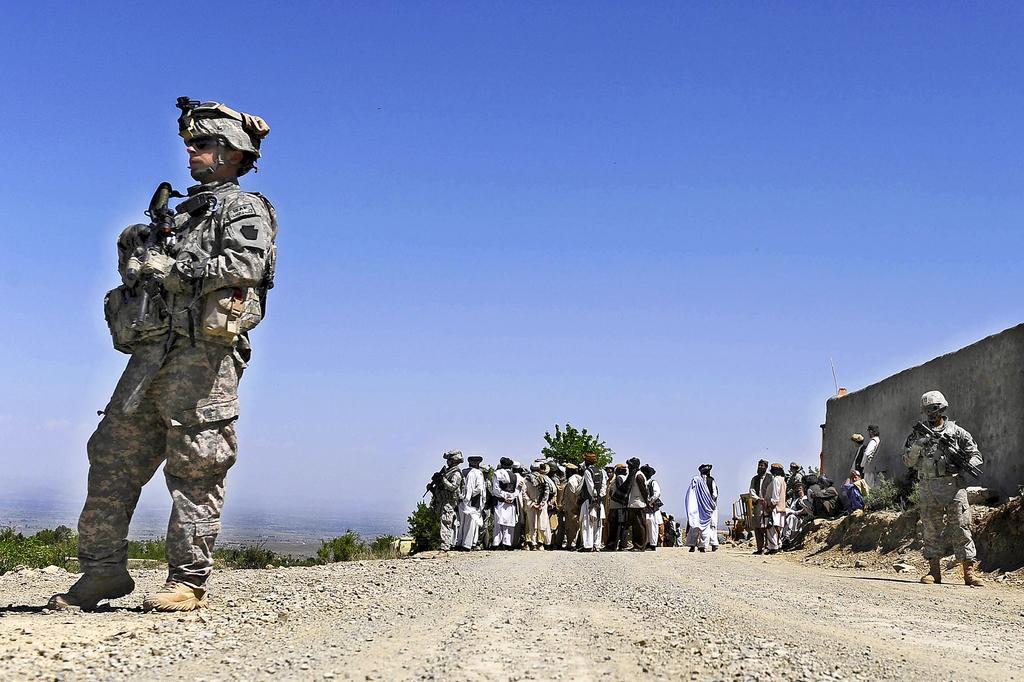Can you describe this image briefly? In this image I can see a person wearing military uniform is standing and holding a gun in his hand. In the background I can see few other persons standing on the road, few trees, a wall and the sky. 